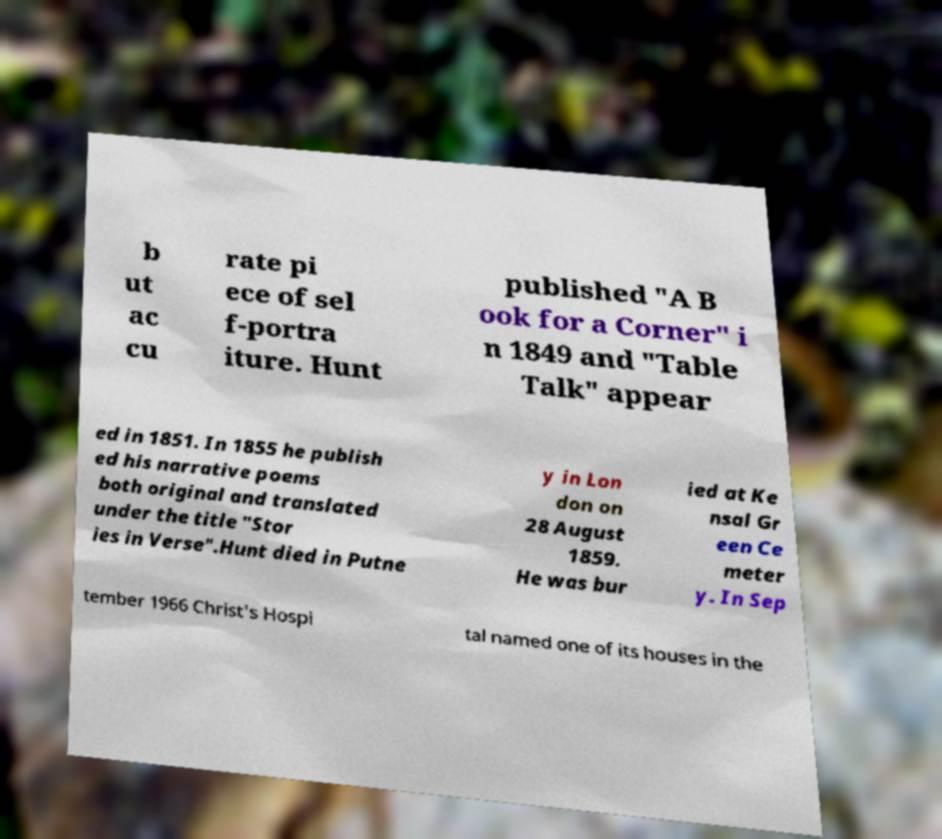There's text embedded in this image that I need extracted. Can you transcribe it verbatim? b ut ac cu rate pi ece of sel f-portra iture. Hunt published "A B ook for a Corner" i n 1849 and "Table Talk" appear ed in 1851. In 1855 he publish ed his narrative poems both original and translated under the title "Stor ies in Verse".Hunt died in Putne y in Lon don on 28 August 1859. He was bur ied at Ke nsal Gr een Ce meter y. In Sep tember 1966 Christ's Hospi tal named one of its houses in the 